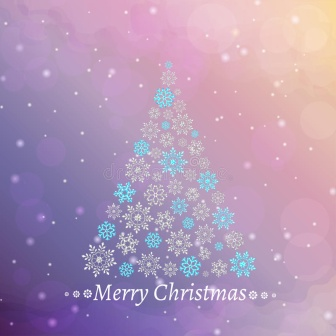Describe a realistic scenario where this image might be displayed indoors. This image could be displayed indoors as a stunning wall art piece in a cozy living room during the Christmas season. Imagine it hanging above a fireplace, where stockings are carefully hung, and the warmth of the fire casts a gentle glow on the artwork. The colors of the image would complement the festive decorations, adding an extra layer of warmth and charm to the room. Family and guests would gather around, enjoying hot cocoa and sharing stories, with the image serving as a beautiful reminder of the holiday spirit. 